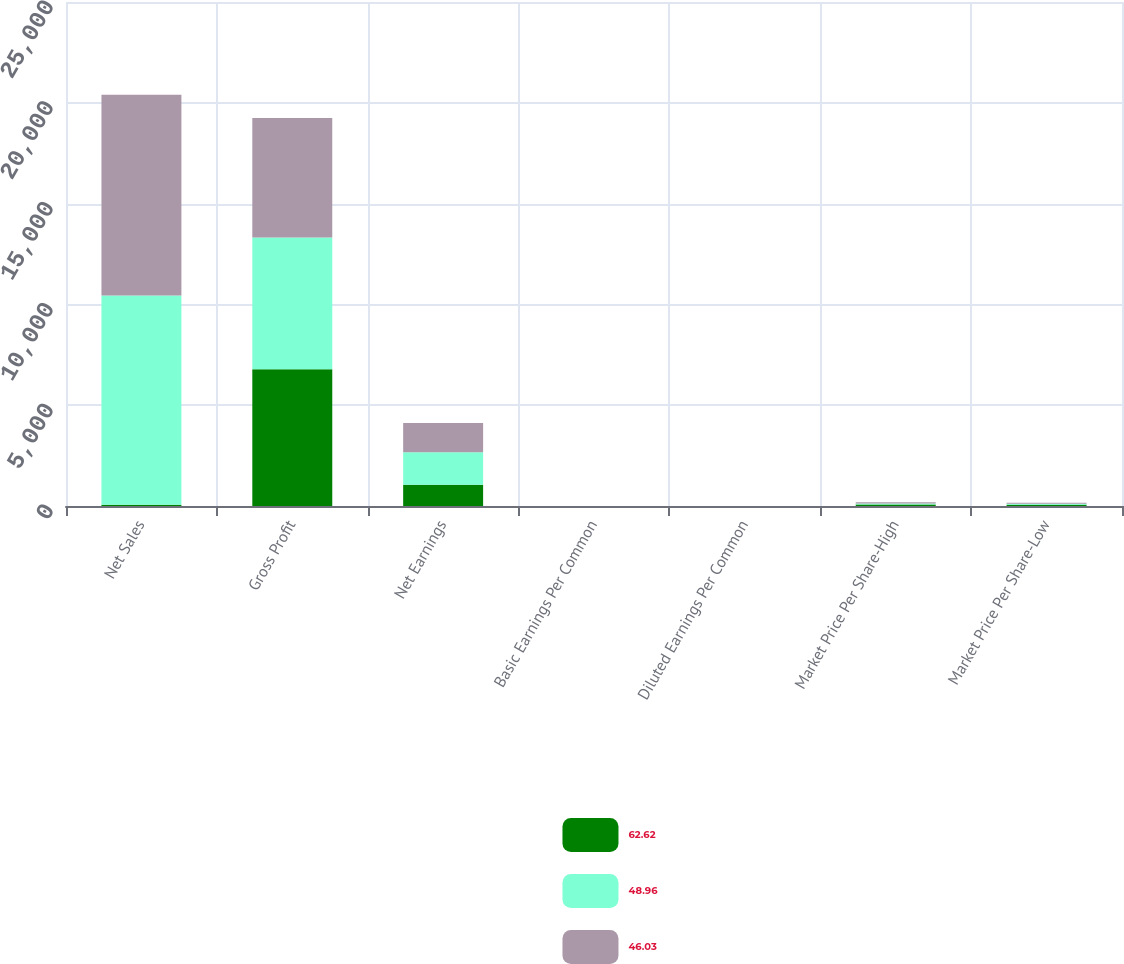Convert chart to OTSL. <chart><loc_0><loc_0><loc_500><loc_500><stacked_bar_chart><ecel><fcel>Net Sales<fcel>Gross Profit<fcel>Net Earnings<fcel>Basic Earnings Per Common<fcel>Diluted Earnings Per Common<fcel>Market Price Per Share-High<fcel>Market Price Per Share-Low<nl><fcel>62.62<fcel>59.53<fcel>6777.5<fcel>1053.4<fcel>0.66<fcel>0.66<fcel>72.47<fcel>62.62<nl><fcel>48.96<fcel>10377.4<fcel>6539.6<fcel>1618.7<fcel>1.03<fcel>1.02<fcel>56.44<fcel>48.96<nl><fcel>46.03<fcel>9967.8<fcel>5922.8<fcel>1440.8<fcel>0.93<fcel>0.92<fcel>53.75<fcel>46.03<nl></chart> 